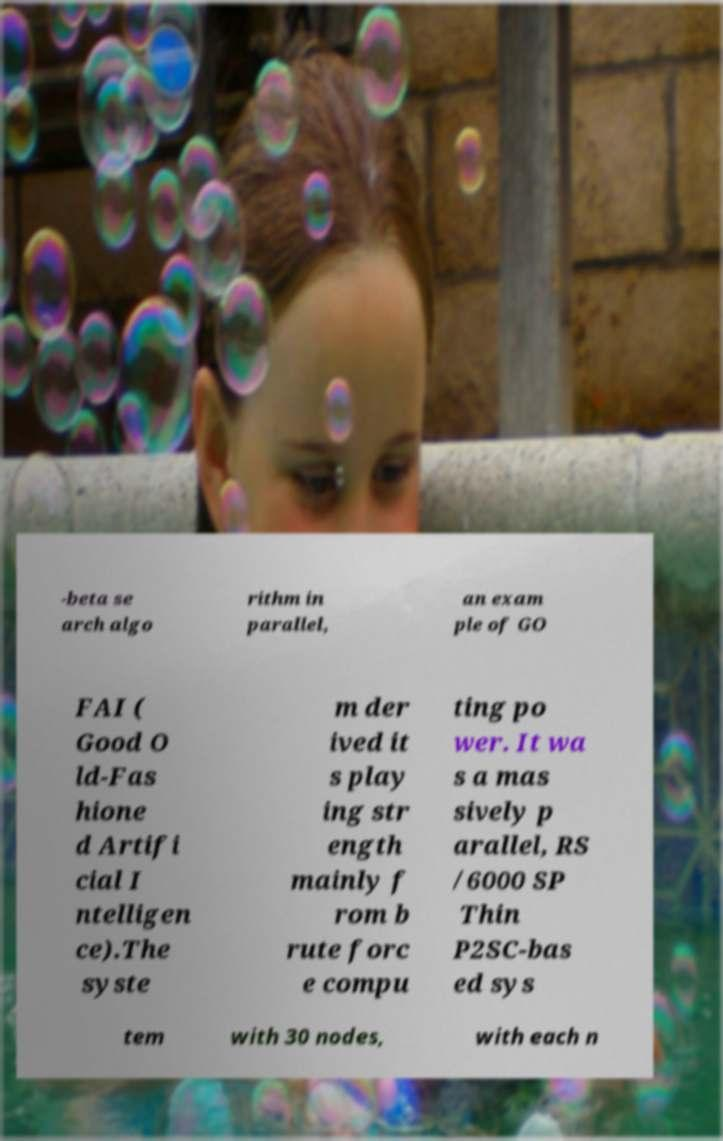Could you extract and type out the text from this image? -beta se arch algo rithm in parallel, an exam ple of GO FAI ( Good O ld-Fas hione d Artifi cial I ntelligen ce).The syste m der ived it s play ing str ength mainly f rom b rute forc e compu ting po wer. It wa s a mas sively p arallel, RS /6000 SP Thin P2SC-bas ed sys tem with 30 nodes, with each n 